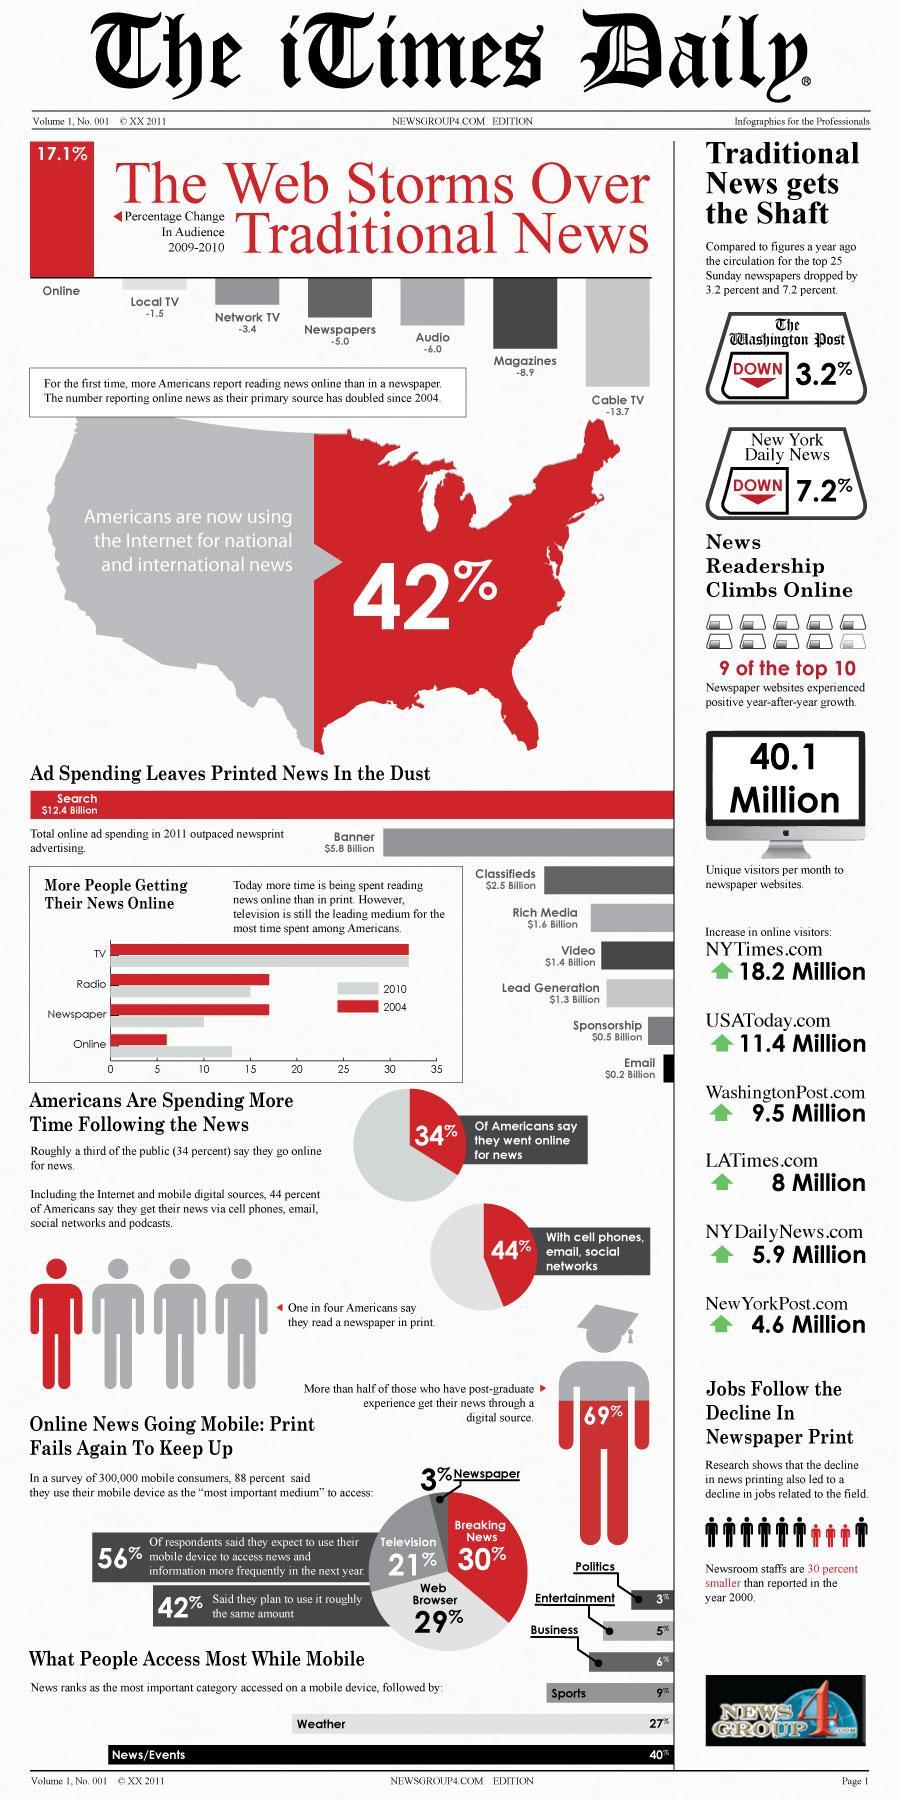Which American newspaper website has seen the highest increase in the number of online visitors per month?
Answer the question with a short phrase. NYTimes.com What is the increase in the online visitors of LATimes per month? 8 Million 